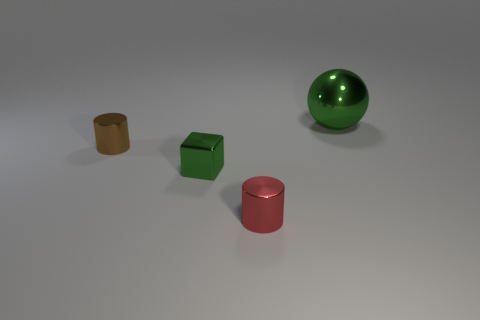Is the shape of the green object that is on the right side of the red object the same as  the small green shiny thing?
Offer a terse response. No. Is the number of cubes that are behind the tiny red shiny object greater than the number of small yellow spheres?
Provide a short and direct response. Yes. What shape is the small metallic object that is the same color as the big thing?
Offer a terse response. Cube. How many spheres are either big green things or tiny green things?
Your answer should be very brief. 1. There is a metal object to the right of the tiny shiny cylinder that is on the right side of the metallic block; what is its color?
Make the answer very short. Green. Does the ball have the same color as the block that is in front of the brown cylinder?
Make the answer very short. Yes. What size is the green ball that is the same material as the tiny green object?
Your response must be concise. Large. The sphere that is the same color as the small cube is what size?
Offer a very short reply. Large. There is a metal cylinder that is left of the small red shiny thing in front of the small green metallic cube; is there a object to the right of it?
Your answer should be compact. Yes. What number of metal cylinders have the same size as the green metal block?
Offer a very short reply. 2. 